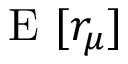<formula> <loc_0><loc_0><loc_500><loc_500>E [ r _ { \mu } ]</formula> 